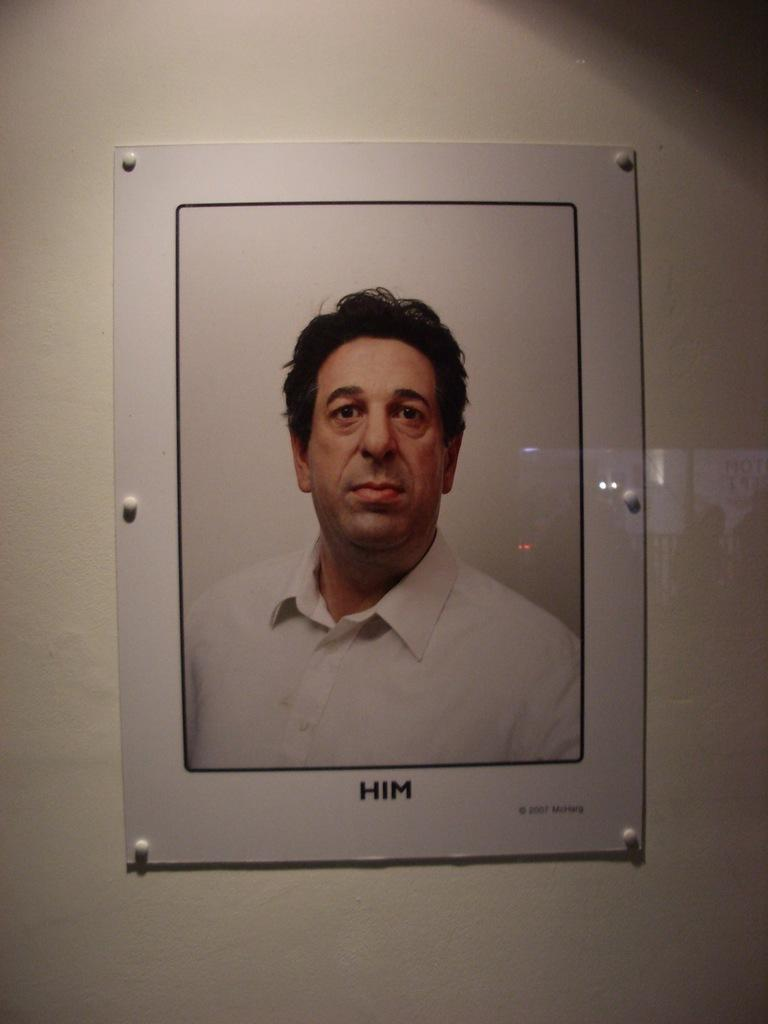What is the main subject of the image? The main subject of the image is a photograph of a person. Where is the photograph located in the image? The photograph is attached to a wall. What type of brain activity can be observed in the image? There is no brain activity visible in the image, as it features a photograph of a person attached to a wall. How does the person in the photograph pull a cart in the image? There is no cart or any indication of pulling in the image; it only shows a photograph of a person attached to a wall. 